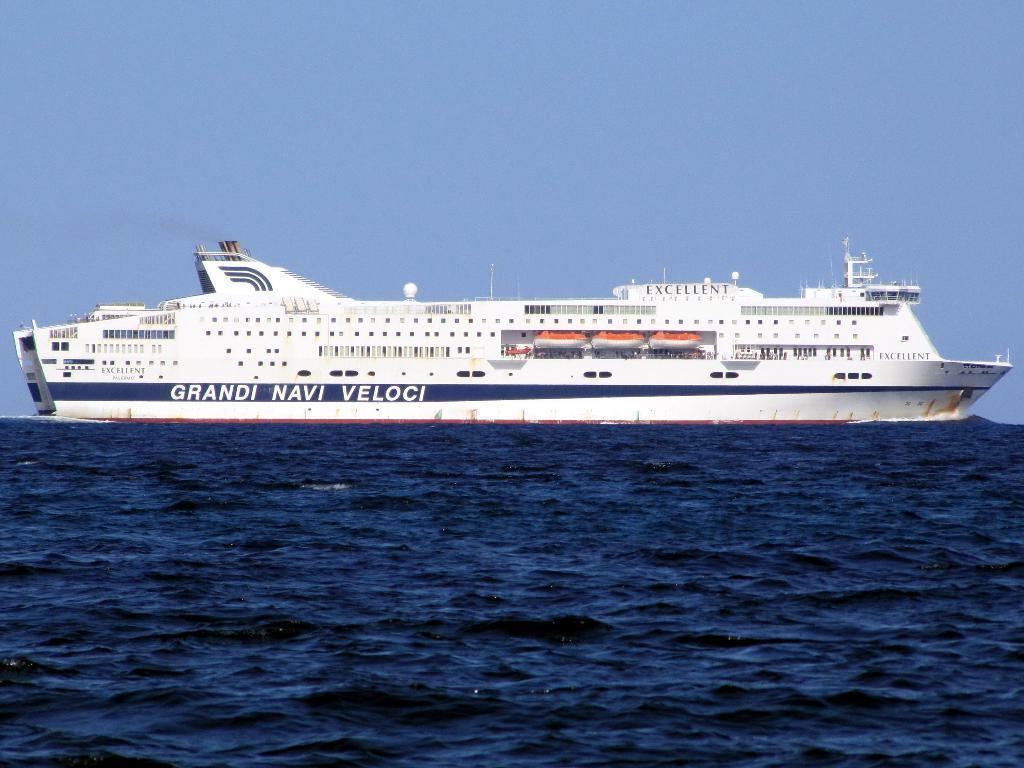What is the main subject of the image? The main subject of the image is a ship. What is the ship doing in the image? The ship is sailing on the water in the image. Is there any text visible on the ship? Yes, there is text written on the ship. What type of cushion can be seen on the ship in the image? There is no cushion visible on the ship in the image. What thrilling activity is taking place on the ship in the image? There is no specific thrilling activity depicted in the image; it simply shows a ship sailing on the water. 